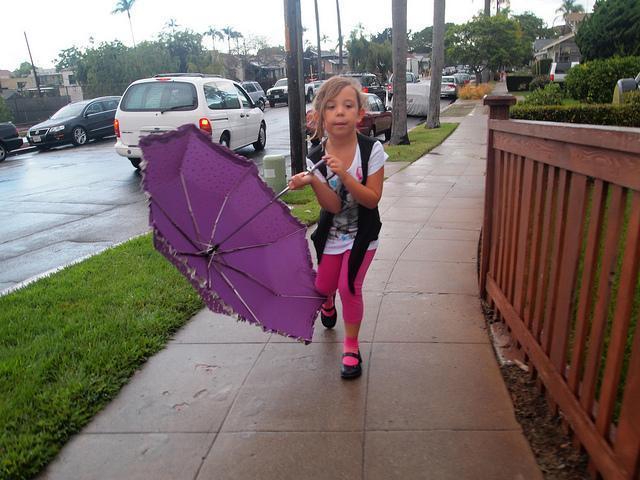How many cars are in the picture?
Give a very brief answer. 2. 